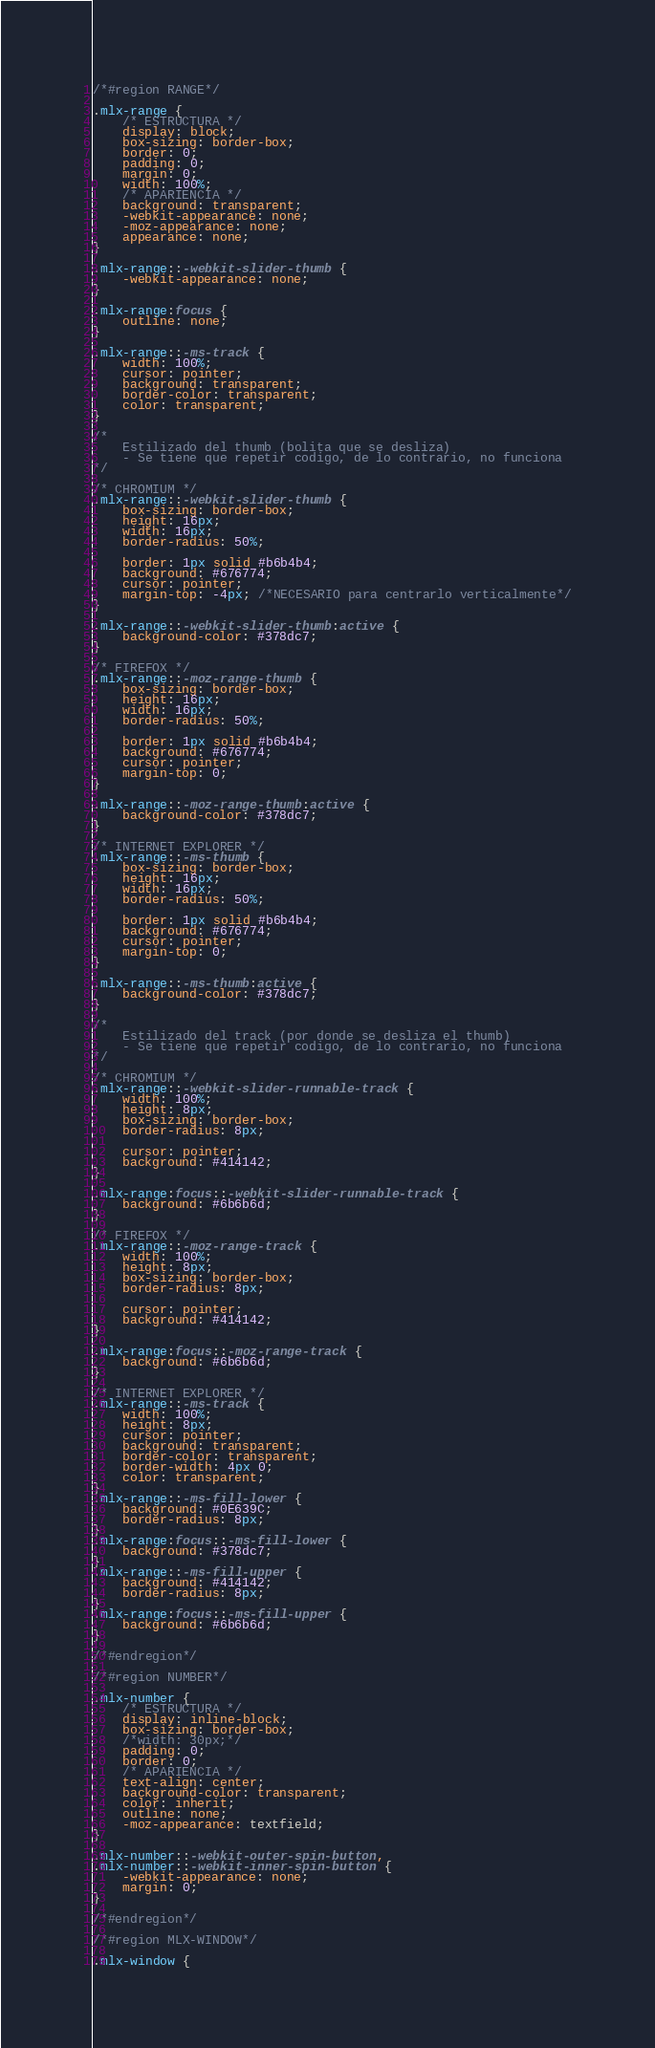<code> <loc_0><loc_0><loc_500><loc_500><_CSS_>/*#region RANGE*/

.mlx-range {
    /* ESTRUCTURA */
    display: block;
    box-sizing: border-box;
    border: 0;
    padding: 0;
    margin: 0;
    width: 100%;
    /* APARIENCIA */
    background: transparent;
    -webkit-appearance: none;
    -moz-appearance: none;
    appearance: none;
}

.mlx-range::-webkit-slider-thumb {
    -webkit-appearance: none;
}

.mlx-range:focus {
    outline: none;
}

.mlx-range::-ms-track {
    width: 100%;
    cursor: pointer;
    background: transparent;
    border-color: transparent;
    color: transparent;
}

/* 
    Estilizado del thumb (bolita que se desliza) 
    - Se tiene que repetir codigo, de lo contrario, no funciona
*/

/* CHROMIUM */
.mlx-range::-webkit-slider-thumb {
    box-sizing: border-box;
    height: 16px;
    width: 16px;
    border-radius: 50%;

    border: 1px solid #b6b4b4;
    background: #676774;
    cursor: pointer;
    margin-top: -4px; /*NECESARIO para centrarlo verticalmente*/
}

.mlx-range::-webkit-slider-thumb:active {
    background-color: #378dc7;
}

/* FIREFOX */
.mlx-range::-moz-range-thumb {
    box-sizing: border-box;
    height: 16px;
    width: 16px;
    border-radius: 50%;

    border: 1px solid #b6b4b4;
    background: #676774;
    cursor: pointer;
    margin-top: 0;
}

.mlx-range::-moz-range-thumb:active {
    background-color: #378dc7;
}

/* INTERNET EXPLORER */
.mlx-range::-ms-thumb {
    box-sizing: border-box;
    height: 16px;
    width: 16px;
    border-radius: 50%;

    border: 1px solid #b6b4b4;
    background: #676774;
    cursor: pointer;
    margin-top: 0;
}

.mlx-range::-ms-thumb:active {
    background-color: #378dc7;
}

/*
    Estilizado del track (por donde se desliza el thumb)
    - Se tiene que repetir codigo, de lo contrario, no funciona
*/

/* CHROMIUM */
.mlx-range::-webkit-slider-runnable-track {
    width: 100%;
    height: 8px;
    box-sizing: border-box;
    border-radius: 8px;

    cursor: pointer;
    background: #414142;
}
  
.mlx-range:focus::-webkit-slider-runnable-track {
    background: #6b6b6d;
}

/* FIREFOX */
.mlx-range::-moz-range-track {
    width: 100%;
    height: 8px;
    box-sizing: border-box;
    border-radius: 8px;

    cursor: pointer;
    background: #414142;
}

.mlx-range:focus::-moz-range-track {
    background: #6b6b6d;
}

/* INTERNET EXPLORER */
.mlx-range::-ms-track {
    width: 100%;
    height: 8px;
    cursor: pointer;
    background: transparent;
    border-color: transparent;
    border-width: 4px 0;
    color: transparent;
}
.mlx-range::-ms-fill-lower {
    background: #0E639C;
    border-radius: 8px;
}
.mlx-range:focus::-ms-fill-lower {
    background: #378dc7;
}
.mlx-range::-ms-fill-upper {
    background: #414142;
    border-radius: 8px;
}
.mlx-range:focus::-ms-fill-upper {
    background: #6b6b6d;
}

/*#endregion*/

/*#region NUMBER*/

.mlx-number {
    /* ESTRUCTURA */
    display: inline-block;
    box-sizing: border-box;
    /*width: 30px;*/
    padding: 0; 
    border: 0; 
    /* APARIENCIA */
    text-align: center; 
    background-color: transparent; 
    color: inherit;
    outline: none;
    -moz-appearance: textfield;
}

.mlx-number::-webkit-outer-spin-button,
.mlx-number::-webkit-inner-spin-button {
    -webkit-appearance: none;
    margin: 0;
}

/*#endregion*/

/*#region MLX-WINDOW*/

.mlx-window {</code> 